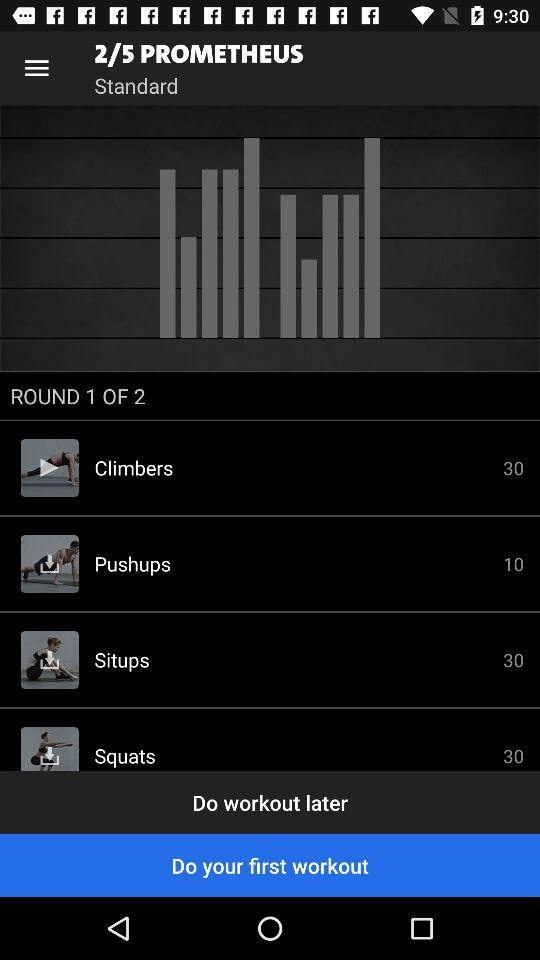How many situps have to be done? There are 30 situps that have to be done. 